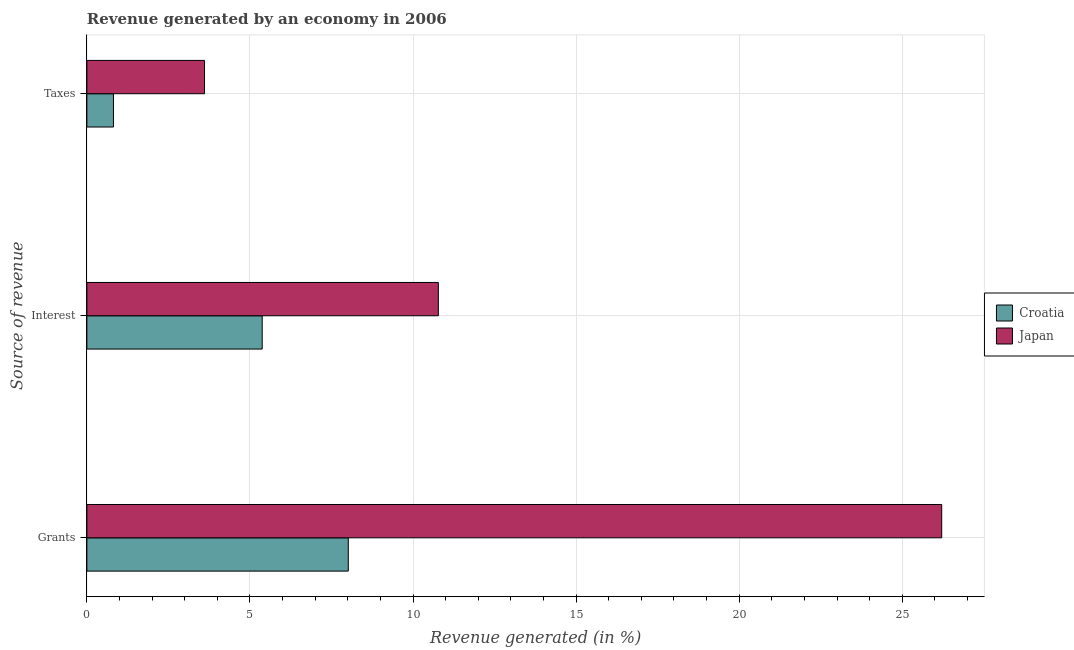How many different coloured bars are there?
Your answer should be compact. 2. Are the number of bars per tick equal to the number of legend labels?
Offer a terse response. Yes. Are the number of bars on each tick of the Y-axis equal?
Your answer should be very brief. Yes. How many bars are there on the 2nd tick from the top?
Provide a short and direct response. 2. How many bars are there on the 1st tick from the bottom?
Provide a succinct answer. 2. What is the label of the 2nd group of bars from the top?
Keep it short and to the point. Interest. What is the percentage of revenue generated by taxes in Japan?
Your response must be concise. 3.61. Across all countries, what is the maximum percentage of revenue generated by interest?
Keep it short and to the point. 10.78. Across all countries, what is the minimum percentage of revenue generated by interest?
Provide a succinct answer. 5.38. In which country was the percentage of revenue generated by grants maximum?
Your answer should be compact. Japan. In which country was the percentage of revenue generated by grants minimum?
Offer a very short reply. Croatia. What is the total percentage of revenue generated by interest in the graph?
Provide a short and direct response. 16.15. What is the difference between the percentage of revenue generated by grants in Croatia and that in Japan?
Your answer should be very brief. -18.19. What is the difference between the percentage of revenue generated by taxes in Japan and the percentage of revenue generated by grants in Croatia?
Offer a very short reply. -4.41. What is the average percentage of revenue generated by interest per country?
Your answer should be very brief. 8.08. What is the difference between the percentage of revenue generated by taxes and percentage of revenue generated by grants in Japan?
Provide a succinct answer. -22.6. What is the ratio of the percentage of revenue generated by grants in Croatia to that in Japan?
Your response must be concise. 0.31. Is the percentage of revenue generated by interest in Japan less than that in Croatia?
Your response must be concise. No. What is the difference between the highest and the second highest percentage of revenue generated by taxes?
Your answer should be compact. 2.79. What is the difference between the highest and the lowest percentage of revenue generated by taxes?
Offer a very short reply. 2.79. Is the sum of the percentage of revenue generated by taxes in Croatia and Japan greater than the maximum percentage of revenue generated by grants across all countries?
Your answer should be very brief. No. What does the 1st bar from the top in Taxes represents?
Provide a succinct answer. Japan. What does the 1st bar from the bottom in Interest represents?
Offer a very short reply. Croatia. How many bars are there?
Give a very brief answer. 6. How many countries are there in the graph?
Your response must be concise. 2. What is the difference between two consecutive major ticks on the X-axis?
Offer a very short reply. 5. Does the graph contain any zero values?
Your answer should be compact. No. Does the graph contain grids?
Provide a short and direct response. Yes. Where does the legend appear in the graph?
Offer a very short reply. Center right. How are the legend labels stacked?
Ensure brevity in your answer.  Vertical. What is the title of the graph?
Your answer should be compact. Revenue generated by an economy in 2006. Does "European Union" appear as one of the legend labels in the graph?
Make the answer very short. No. What is the label or title of the X-axis?
Give a very brief answer. Revenue generated (in %). What is the label or title of the Y-axis?
Offer a terse response. Source of revenue. What is the Revenue generated (in %) of Croatia in Grants?
Ensure brevity in your answer.  8.02. What is the Revenue generated (in %) in Japan in Grants?
Make the answer very short. 26.21. What is the Revenue generated (in %) of Croatia in Interest?
Provide a short and direct response. 5.38. What is the Revenue generated (in %) of Japan in Interest?
Your response must be concise. 10.78. What is the Revenue generated (in %) of Croatia in Taxes?
Provide a succinct answer. 0.81. What is the Revenue generated (in %) in Japan in Taxes?
Ensure brevity in your answer.  3.61. Across all Source of revenue, what is the maximum Revenue generated (in %) in Croatia?
Your answer should be very brief. 8.02. Across all Source of revenue, what is the maximum Revenue generated (in %) of Japan?
Provide a succinct answer. 26.21. Across all Source of revenue, what is the minimum Revenue generated (in %) in Croatia?
Offer a terse response. 0.81. Across all Source of revenue, what is the minimum Revenue generated (in %) of Japan?
Keep it short and to the point. 3.61. What is the total Revenue generated (in %) of Croatia in the graph?
Your response must be concise. 14.21. What is the total Revenue generated (in %) of Japan in the graph?
Your answer should be compact. 40.59. What is the difference between the Revenue generated (in %) in Croatia in Grants and that in Interest?
Offer a very short reply. 2.64. What is the difference between the Revenue generated (in %) of Japan in Grants and that in Interest?
Your answer should be compact. 15.43. What is the difference between the Revenue generated (in %) of Croatia in Grants and that in Taxes?
Provide a short and direct response. 7.2. What is the difference between the Revenue generated (in %) of Japan in Grants and that in Taxes?
Provide a short and direct response. 22.6. What is the difference between the Revenue generated (in %) of Croatia in Interest and that in Taxes?
Provide a short and direct response. 4.56. What is the difference between the Revenue generated (in %) in Japan in Interest and that in Taxes?
Your response must be concise. 7.17. What is the difference between the Revenue generated (in %) in Croatia in Grants and the Revenue generated (in %) in Japan in Interest?
Keep it short and to the point. -2.76. What is the difference between the Revenue generated (in %) of Croatia in Grants and the Revenue generated (in %) of Japan in Taxes?
Your answer should be compact. 4.41. What is the difference between the Revenue generated (in %) of Croatia in Interest and the Revenue generated (in %) of Japan in Taxes?
Offer a terse response. 1.77. What is the average Revenue generated (in %) in Croatia per Source of revenue?
Provide a short and direct response. 4.74. What is the average Revenue generated (in %) of Japan per Source of revenue?
Ensure brevity in your answer.  13.53. What is the difference between the Revenue generated (in %) of Croatia and Revenue generated (in %) of Japan in Grants?
Ensure brevity in your answer.  -18.19. What is the difference between the Revenue generated (in %) of Croatia and Revenue generated (in %) of Japan in Interest?
Your response must be concise. -5.4. What is the difference between the Revenue generated (in %) of Croatia and Revenue generated (in %) of Japan in Taxes?
Your answer should be very brief. -2.79. What is the ratio of the Revenue generated (in %) of Croatia in Grants to that in Interest?
Make the answer very short. 1.49. What is the ratio of the Revenue generated (in %) of Japan in Grants to that in Interest?
Offer a terse response. 2.43. What is the ratio of the Revenue generated (in %) in Croatia in Grants to that in Taxes?
Provide a short and direct response. 9.84. What is the ratio of the Revenue generated (in %) of Japan in Grants to that in Taxes?
Offer a terse response. 7.27. What is the ratio of the Revenue generated (in %) in Croatia in Interest to that in Taxes?
Ensure brevity in your answer.  6.6. What is the ratio of the Revenue generated (in %) in Japan in Interest to that in Taxes?
Provide a short and direct response. 2.99. What is the difference between the highest and the second highest Revenue generated (in %) in Croatia?
Your answer should be very brief. 2.64. What is the difference between the highest and the second highest Revenue generated (in %) of Japan?
Provide a succinct answer. 15.43. What is the difference between the highest and the lowest Revenue generated (in %) in Croatia?
Keep it short and to the point. 7.2. What is the difference between the highest and the lowest Revenue generated (in %) in Japan?
Offer a terse response. 22.6. 